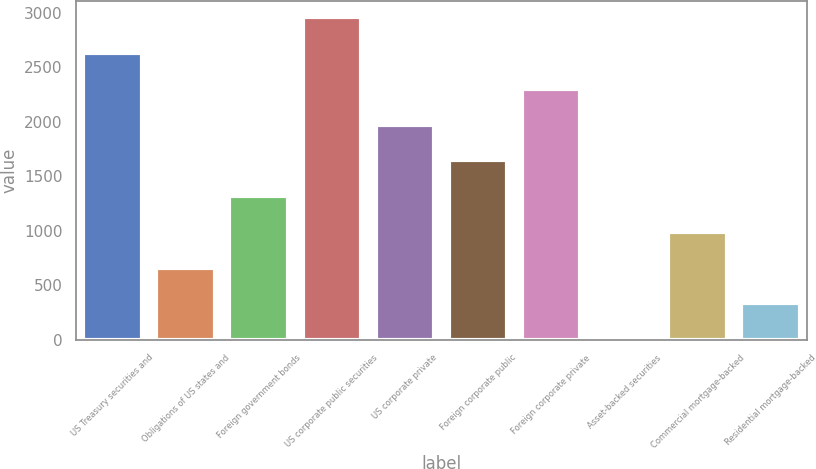Convert chart to OTSL. <chart><loc_0><loc_0><loc_500><loc_500><bar_chart><fcel>US Treasury securities and<fcel>Obligations of US states and<fcel>Foreign government bonds<fcel>US corporate public securities<fcel>US corporate private<fcel>Foreign corporate public<fcel>Foreign corporate private<fcel>Asset-backed securities<fcel>Commercial mortgage-backed<fcel>Residential mortgage-backed<nl><fcel>2627.8<fcel>662.2<fcel>1317.4<fcel>2955.4<fcel>1972.6<fcel>1645<fcel>2300.2<fcel>7<fcel>989.8<fcel>334.6<nl></chart> 